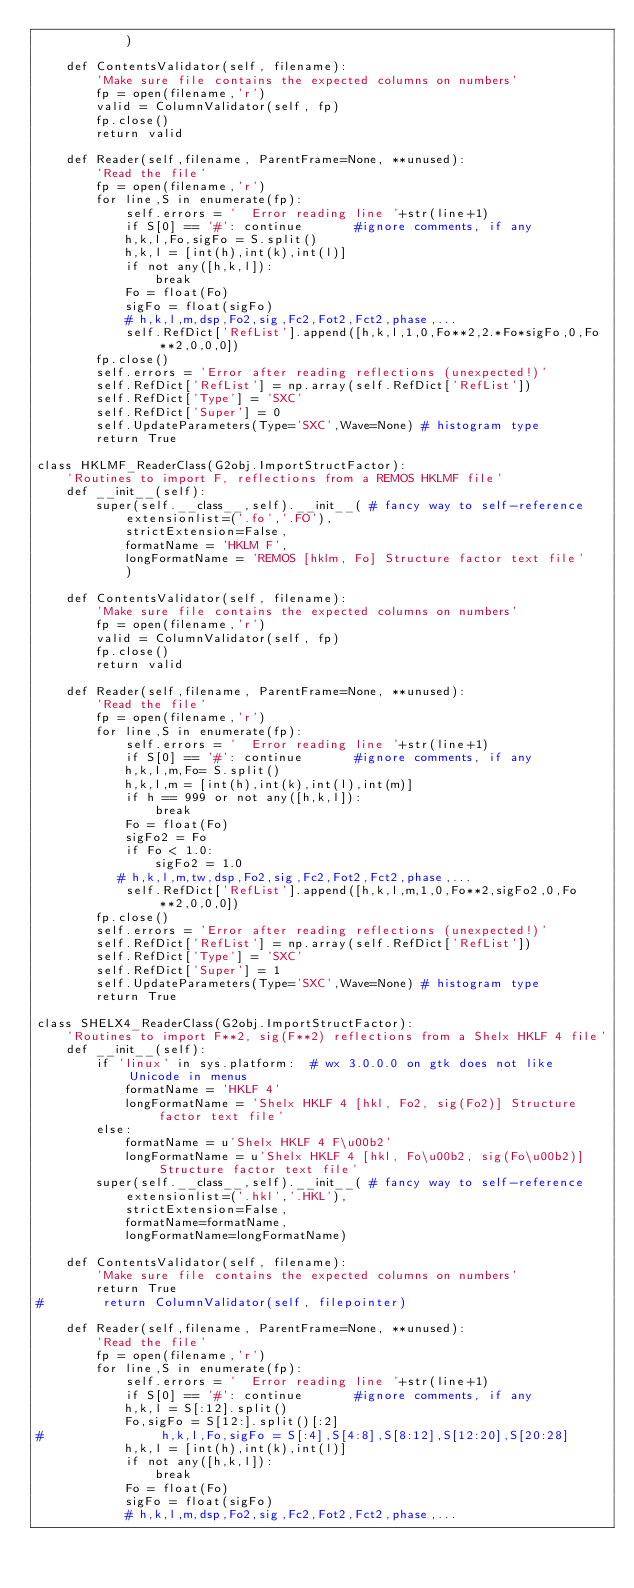<code> <loc_0><loc_0><loc_500><loc_500><_Python_>            )

    def ContentsValidator(self, filename):
        'Make sure file contains the expected columns on numbers'
        fp = open(filename,'r')
        valid = ColumnValidator(self, fp)
        fp.close()
        return valid

    def Reader(self,filename, ParentFrame=None, **unused):
        'Read the file'
        fp = open(filename,'r')
        for line,S in enumerate(fp):
            self.errors = '  Error reading line '+str(line+1)
            if S[0] == '#': continue       #ignore comments, if any
            h,k,l,Fo,sigFo = S.split()
            h,k,l = [int(h),int(k),int(l)]
            if not any([h,k,l]):
                break
            Fo = float(Fo)
            sigFo = float(sigFo)
            # h,k,l,m,dsp,Fo2,sig,Fc2,Fot2,Fct2,phase,...
            self.RefDict['RefList'].append([h,k,l,1,0,Fo**2,2.*Fo*sigFo,0,Fo**2,0,0,0])
        fp.close()
        self.errors = 'Error after reading reflections (unexpected!)'
        self.RefDict['RefList'] = np.array(self.RefDict['RefList'])
        self.RefDict['Type'] = 'SXC'
        self.RefDict['Super'] = 0
        self.UpdateParameters(Type='SXC',Wave=None) # histogram type
        return True

class HKLMF_ReaderClass(G2obj.ImportStructFactor):
    'Routines to import F, reflections from a REMOS HKLMF file'
    def __init__(self):
        super(self.__class__,self).__init__( # fancy way to self-reference
            extensionlist=('.fo','.FO'),
            strictExtension=False,
            formatName = 'HKLM F',
            longFormatName = 'REMOS [hklm, Fo] Structure factor text file'
            )

    def ContentsValidator(self, filename):
        'Make sure file contains the expected columns on numbers'
        fp = open(filename,'r')
        valid = ColumnValidator(self, fp)
        fp.close()
        return valid

    def Reader(self,filename, ParentFrame=None, **unused):
        'Read the file'
        fp = open(filename,'r')
        for line,S in enumerate(fp):
            self.errors = '  Error reading line '+str(line+1)
            if S[0] == '#': continue       #ignore comments, if any
            h,k,l,m,Fo= S.split()
            h,k,l,m = [int(h),int(k),int(l),int(m)]
            if h == 999 or not any([h,k,l]):
                break
            Fo = float(Fo)
            sigFo2 = Fo
            if Fo < 1.0:
                sigFo2 = 1.0
           # h,k,l,m,tw,dsp,Fo2,sig,Fc2,Fot2,Fct2,phase,...
            self.RefDict['RefList'].append([h,k,l,m,1,0,Fo**2,sigFo2,0,Fo**2,0,0,0])
        fp.close()
        self.errors = 'Error after reading reflections (unexpected!)'
        self.RefDict['RefList'] = np.array(self.RefDict['RefList'])
        self.RefDict['Type'] = 'SXC'
        self.RefDict['Super'] = 1
        self.UpdateParameters(Type='SXC',Wave=None) # histogram type
        return True

class SHELX4_ReaderClass(G2obj.ImportStructFactor):
    'Routines to import F**2, sig(F**2) reflections from a Shelx HKLF 4 file'
    def __init__(self):
        if 'linux' in sys.platform:  # wx 3.0.0.0 on gtk does not like Unicode in menus
            formatName = 'HKLF 4'
            longFormatName = 'Shelx HKLF 4 [hkl, Fo2, sig(Fo2)] Structure factor text file'
        else:
            formatName = u'Shelx HKLF 4 F\u00b2'
            longFormatName = u'Shelx HKLF 4 [hkl, Fo\u00b2, sig(Fo\u00b2)] Structure factor text file'
        super(self.__class__,self).__init__( # fancy way to self-reference
            extensionlist=('.hkl','.HKL'),
            strictExtension=False,
            formatName=formatName,
            longFormatName=longFormatName)

    def ContentsValidator(self, filename):
        'Make sure file contains the expected columns on numbers'
        return True
#        return ColumnValidator(self, filepointer)

    def Reader(self,filename, ParentFrame=None, **unused):
        'Read the file'
        fp = open(filename,'r')
        for line,S in enumerate(fp):
            self.errors = '  Error reading line '+str(line+1)
            if S[0] == '#': continue       #ignore comments, if any
            h,k,l = S[:12].split()
            Fo,sigFo = S[12:].split()[:2]
#                h,k,l,Fo,sigFo = S[:4],S[4:8],S[8:12],S[12:20],S[20:28]
            h,k,l = [int(h),int(k),int(l)]
            if not any([h,k,l]):
                break
            Fo = float(Fo)
            sigFo = float(sigFo)
            # h,k,l,m,dsp,Fo2,sig,Fc2,Fot2,Fct2,phase,...</code> 